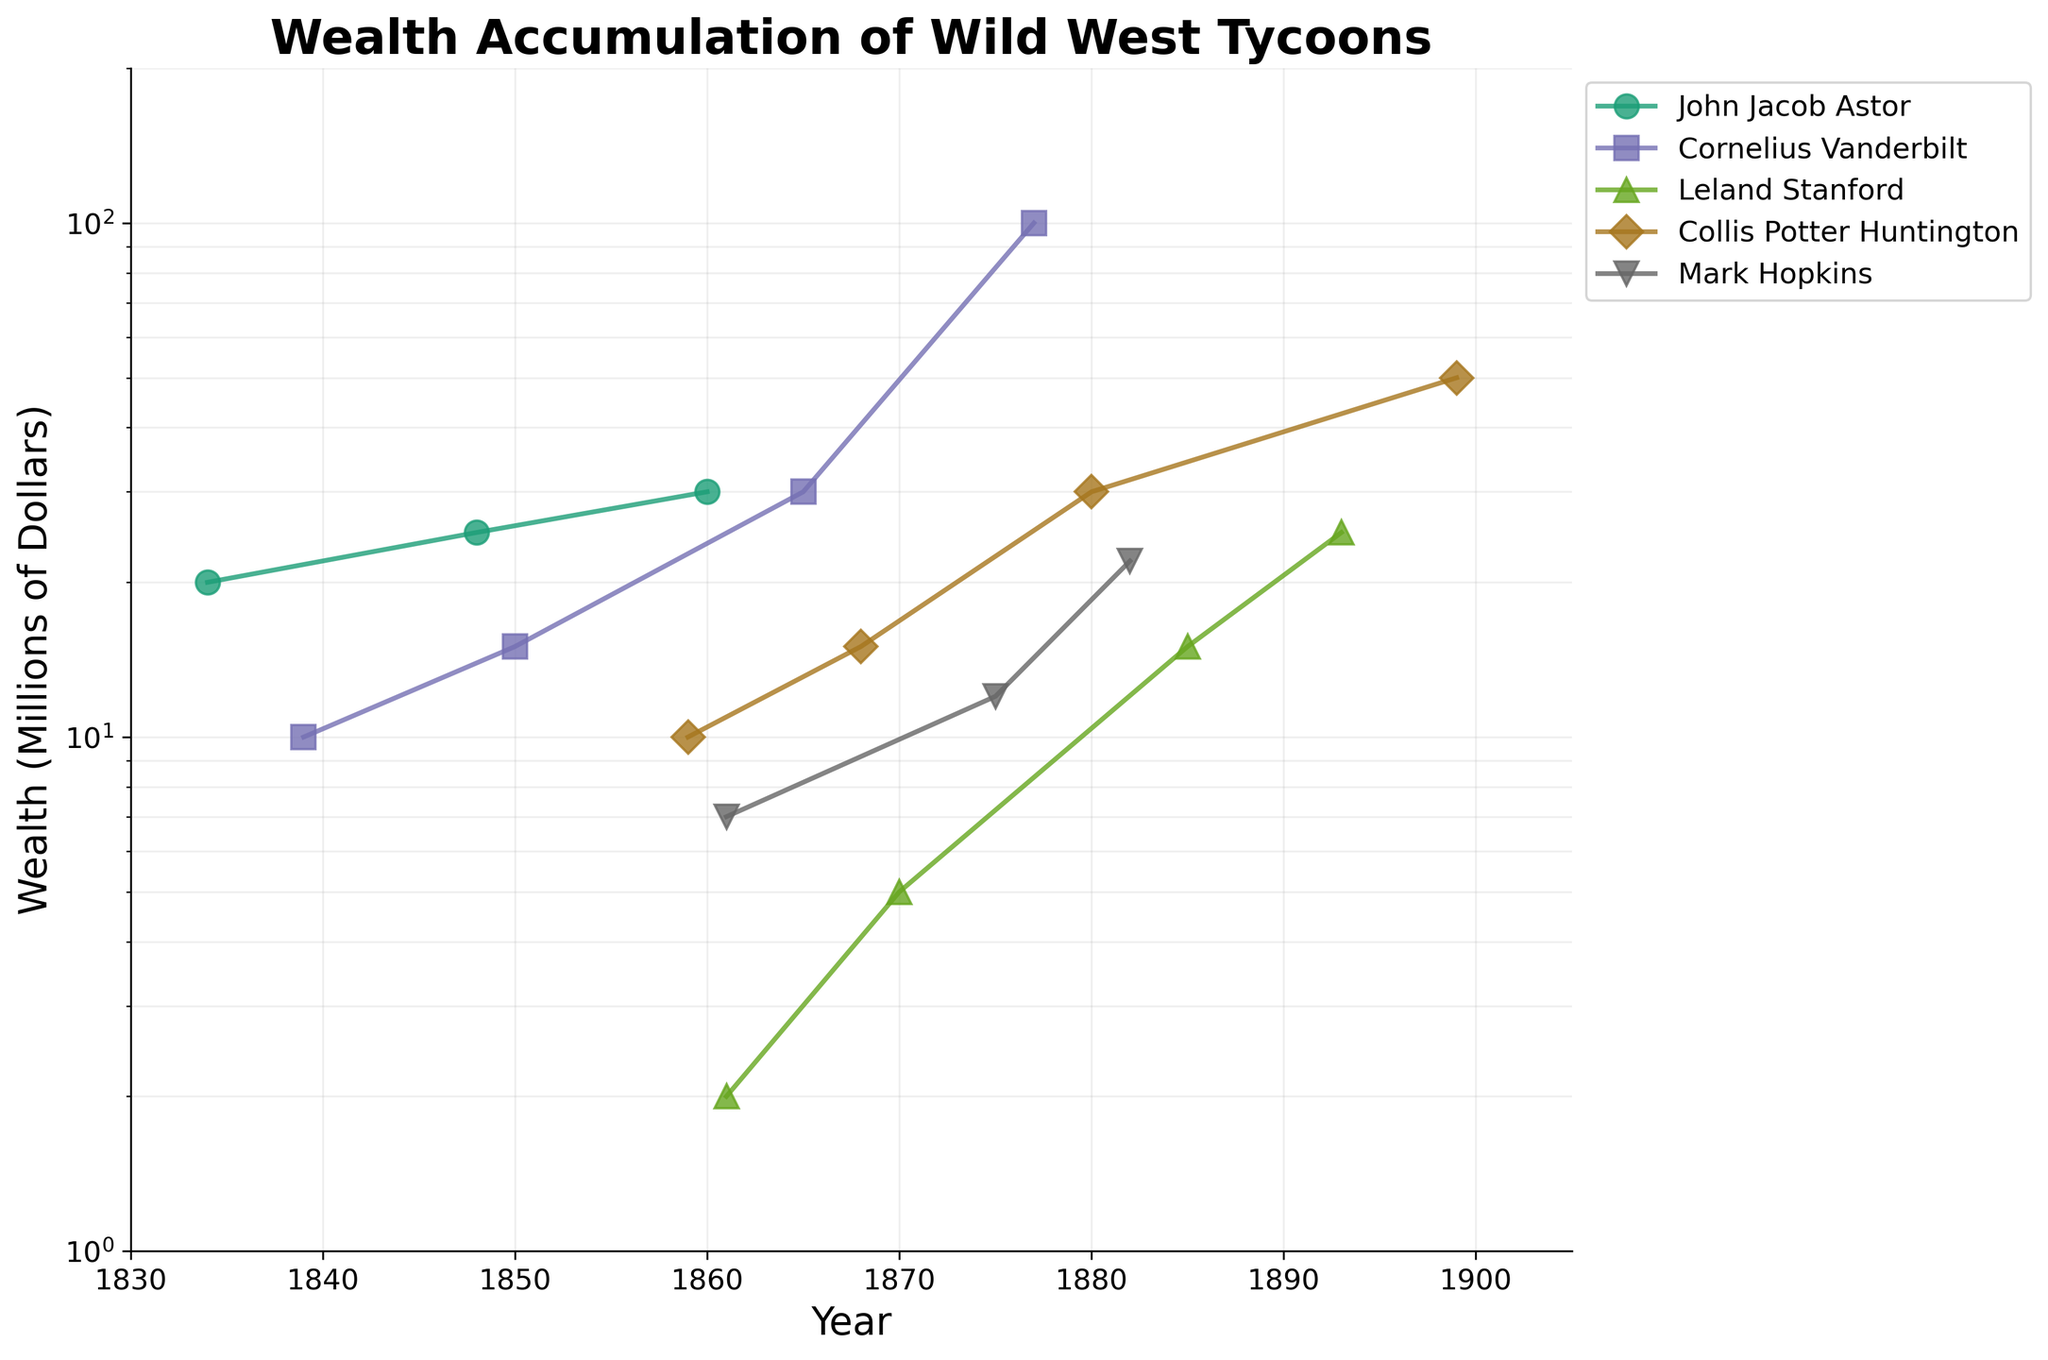Which tycoon had the highest wealth in the year 1877? The figure shows the wealth accumulation of each tycoon and their respective data points. Look for the highest data point in the year 1877. Cornelius Vanderbilt reached 100 million dollars, which is the highest wealth shown for that year.
Answer: Cornelius Vanderbilt What is the title of the plot illustrating wealth accumulation? The title is usually located at the top of the plot. In this case, it clearly states "Wealth Accumulation of Wild West Tycoons."
Answer: Wealth Accumulation of Wild West Tycoons Which tycoon showed the largest increase in wealth between their first and last recorded data points? To answer this, we need to compare the initial and final data points of each tycoon and find the difference. Cornelius Vanderbilt shows the largest increase from 10 million in 1839 to 100 million in 1877, an increase of 90 million.
Answer: Cornelius Vanderbilt Were there any years where multiple tycoons had the same wealth? Check the plotted data points for overlapping or close points in wealth for the same year. There are no years where multiple tycoons had exactly the same wealth at any point according to the plotted data.
Answer: No How does the wealth accumulation pattern of John Jacob Astor compare to that of Leland Stanford? Compare the plotted wealth data points over the years for both tycoons. John Jacob Astor's wealth grows steadily, but Leland Stanford starts with lower wealth and then accelerates over time. Astor’s pattern is slower and more consistent, while Stanford shows a quicker rise later in his timeline.
Answer: Astor: Consistent, slower; Stanford: Accelerates faster In what year did Mark Hopkins have the highest recorded wealth, and what was the amount? Locate Mark Hopkins' data points and find the one with the highest wealth. The highest point for him indicates that in the year 1882, Mark Hopkins had 22 million dollars.
Answer: 1882, 22 million What is the range of years covered in this plot? The x-axis shows the range of years. From the earliest data points in 1834 (John Jacob Astor) to the latest in 1899 (Collis Potter Huntington).
Answer: 1834 to 1899 Which tycoon had a wealth of 30 million dollars in 1880? Locate the data point at 1880 on the x-axis and look for the corresponding wealth. Collis Potter Huntington had 30 million dollars in 1880.
Answer: Collis Potter Huntington Is there a pattern in the rate of wealth accumulation among the tycoons, considering the log scale? Since the scale is logarithmic, accumulation appears as exponential increases rather than linear. Many tycoons, like Vanderbilt and Huntington, show steeper rises in wealth compared to a simpler linear scale, implying rapid accumulation phases.
Answer: Exponential increases In the final years of recorded data, how does Leland Stanford's wealth compare to Collis Potter Huntington’s? Examine the final data points for both tycoons. Leland Stanford’s wealth in 1893 was 25 million, while Collis Potter Huntington’s was 50 million in 1899. Huntington had higher wealth.
Answer: Leland Stanford: 25 million; Huntington: 50 million 